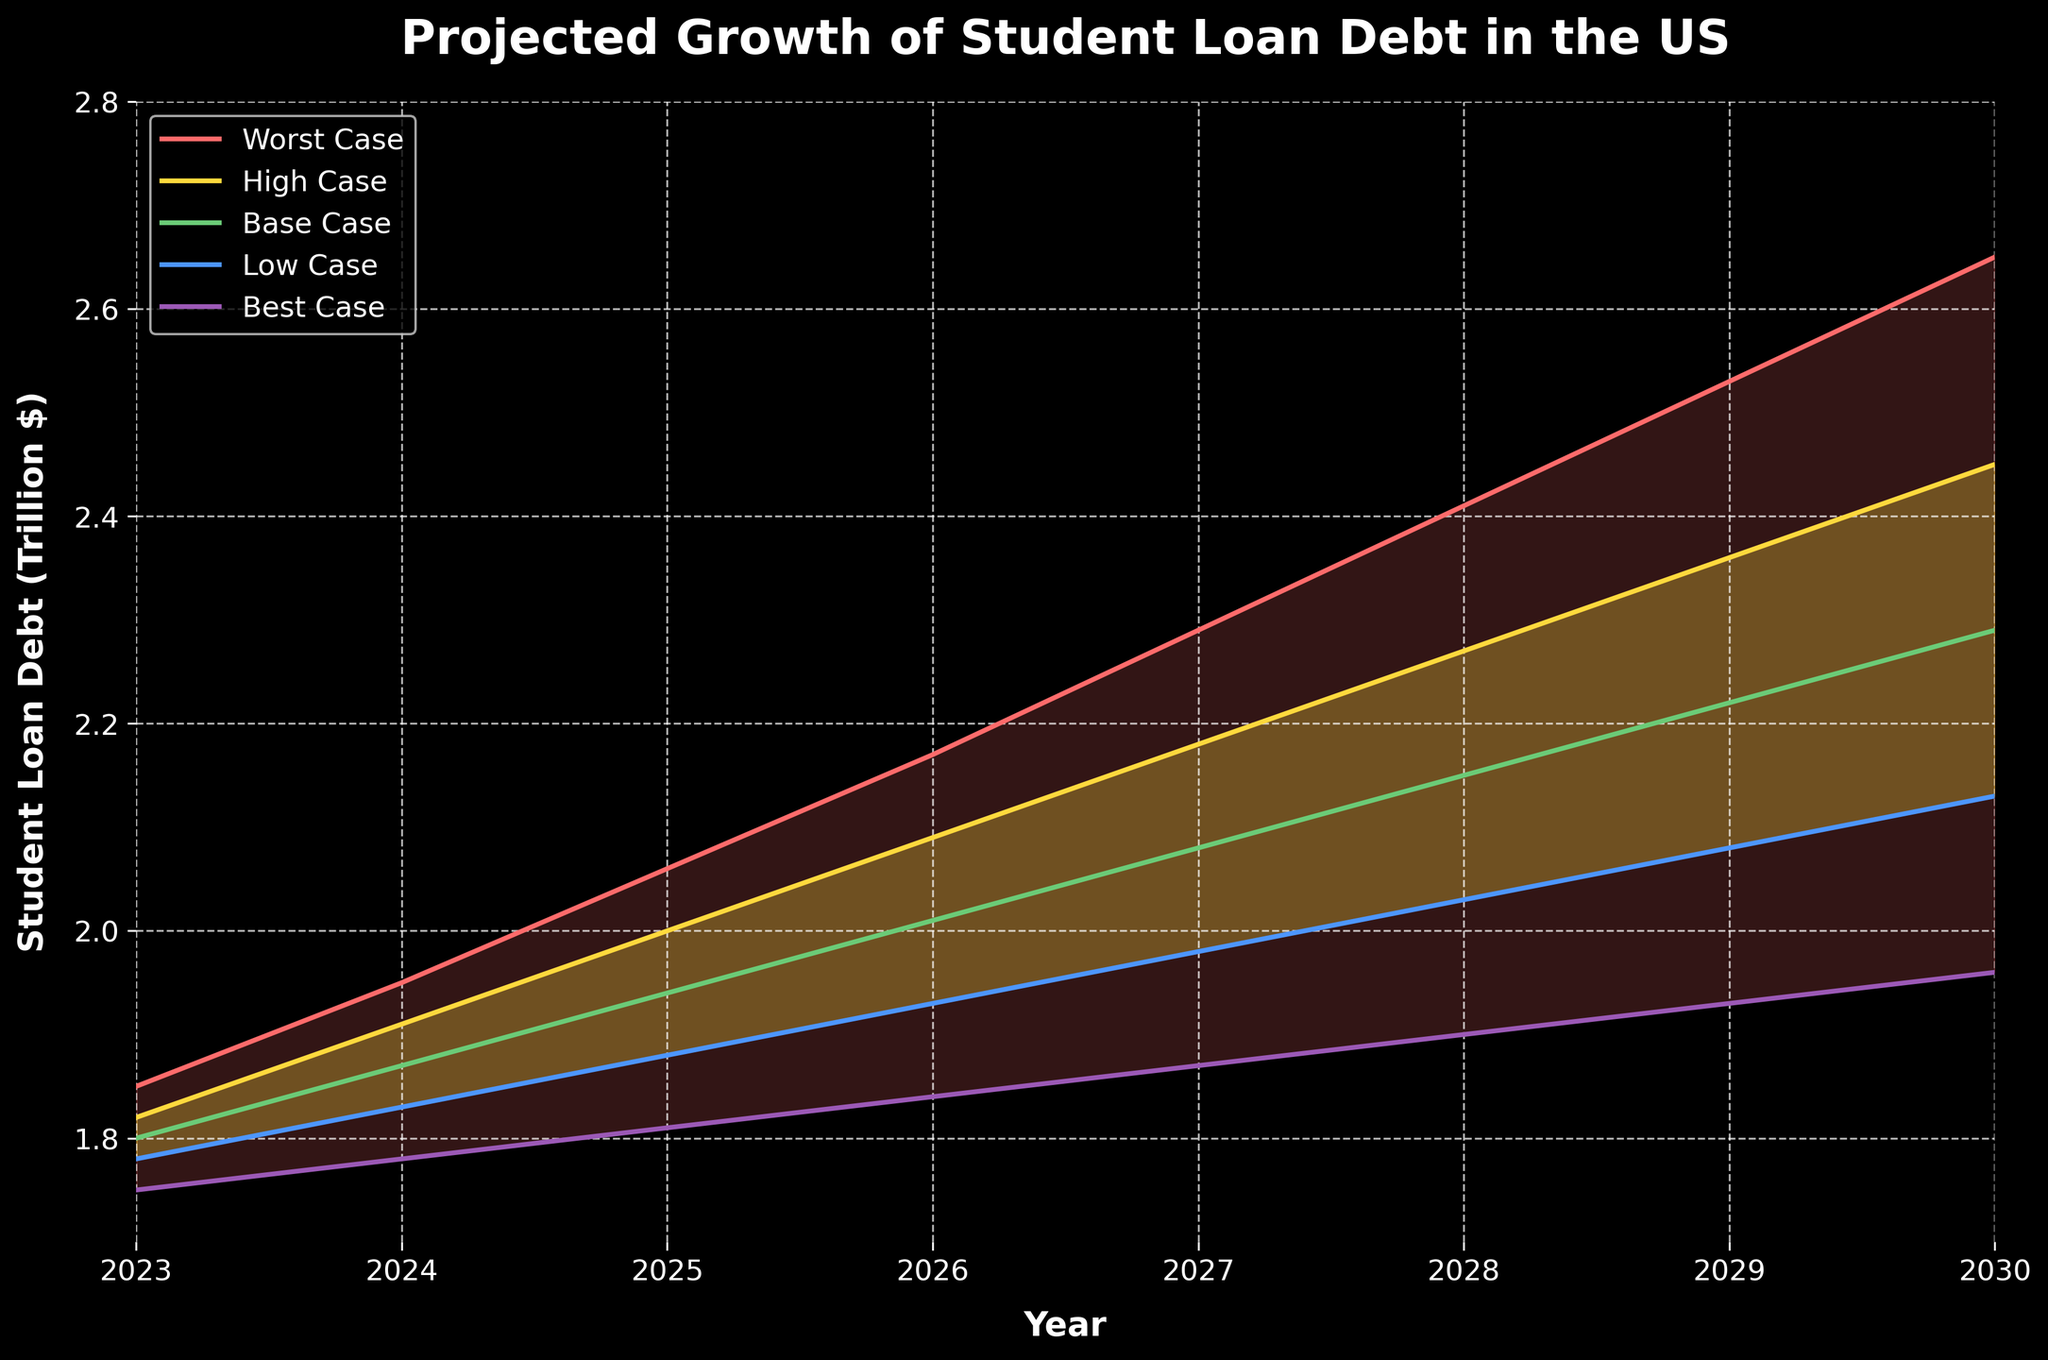What is the title of the chart? The title is displayed prominently at the top of the figure in large, bold text.
Answer: Projected Growth of Student Loan Debt in the US What is the projected student loan debt in the best-case scenario for the year 2029? Locate the data point corresponding to the best-case scenario line at the year 2029.
Answer: 1.93 trillion dollars Which scenario shows the highest projected student loan debt for the year 2026? Compare the projected values for the year 2026 across all scenarios and identify the highest value.
Answer: Worst Case What is the range of projected student loan debt in 2028? Find the difference between the worst-case and best-case scenarios for the year 2028 by subtracting the best-case value from the worst-case value.
Answer: 2.41 - 1.90 = 0.51 trillion dollars How does the student loan debt change from 2023 to 2030 in the base case? Note the base case values for 2023 and 2030, and subtract the 2023 value from the 2030 value.
Answer: 2.29 - 1.80 = 0.49 trillion dollars In which year does the high-case scenario first exceed 2 trillion dollars? Look at the high-case scenario line and identify the first year where the value is greater than 2 trillion dollars.
Answer: 2026 What is the average projected student loan debt for the worst-case scenario over the entire period? Add up all the values for the worst-case scenario from 2023 to 2030 and divide by the number of years.
Answer: (1.85 + 1.95 + 2.06 + 2.17 + 2.29 + 2.41 + 2.53 + 2.65) / 8 = 2.23625 trillion dollars How wide is the spread between the best-case and worst-case scenarios in 2027? Locate the values for the best-case and worst-case scenarios in 2027 and subtract the best-case value from the worst-case value.
Answer: 2.29 - 1.87 = 0.42 trillion dollars Does the low-case scenario at any point meet or exceed the base-case projection for 2025? Compare the low-case value and base-case value for 2025.
Answer: No By how much does the projected debt in the high-case scenario increase from 2024 to 2029? Subtract the high-case value in 2024 from the high-case value in 2029.
Answer: 2.36 - 1.91 = 0.45 trillion dollars 